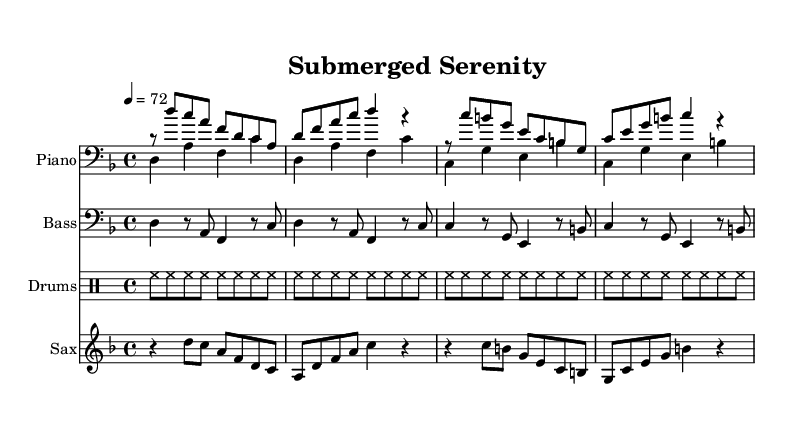What is the key signature of this music? The key signature indicates D minor, which has one flat (B flat). This can be identified by looking at the key signature notation at the beginning of the staff in the sheet music.
Answer: D minor What is the time signature of this music? The time signature is found at the beginning of the score, showing how many beats are in each measure. In this case, it's indicated as 4/4, which means there are four beats per measure and the quarter note gets one beat.
Answer: 4/4 What is the tempo marking for this piece? The tempo marking is specified with a metronome marking at the beginning, indicating the speed of the music. In this score, it is set to 72 beats per minute.
Answer: 72 How many measures are in the score? By counting the distinct grouping of notes surrounded by bar lines throughout the score, we find there are 16 measures total.
Answer: 16 What is the primary instrument featured in this composition? The sheet music displays multiple staves, but the instrument designated as the primary feature is the piano, as it has the first staff named "Piano" in the score layout.
Answer: Piano What is the function of the saxophone in this piece? The saxophone plays melodic phrases in higher register notes, often responding or complementing the harmony laid by the piano, bass, and drums, typical for a jazz piece aiming to create relaxing themes.
Answer: Melody 